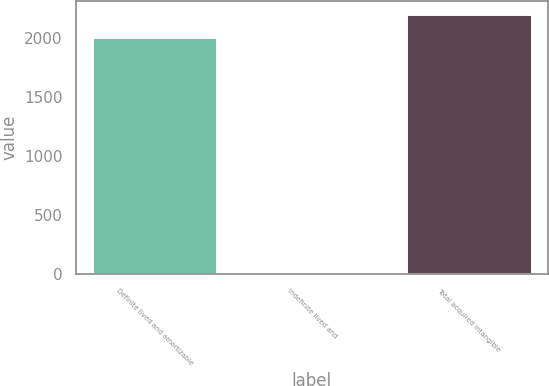<chart> <loc_0><loc_0><loc_500><loc_500><bar_chart><fcel>Definite lived and amortizable<fcel>Indefinite lived and<fcel>Total acquired intangible<nl><fcel>2002<fcel>4.69<fcel>2201.73<nl></chart> 